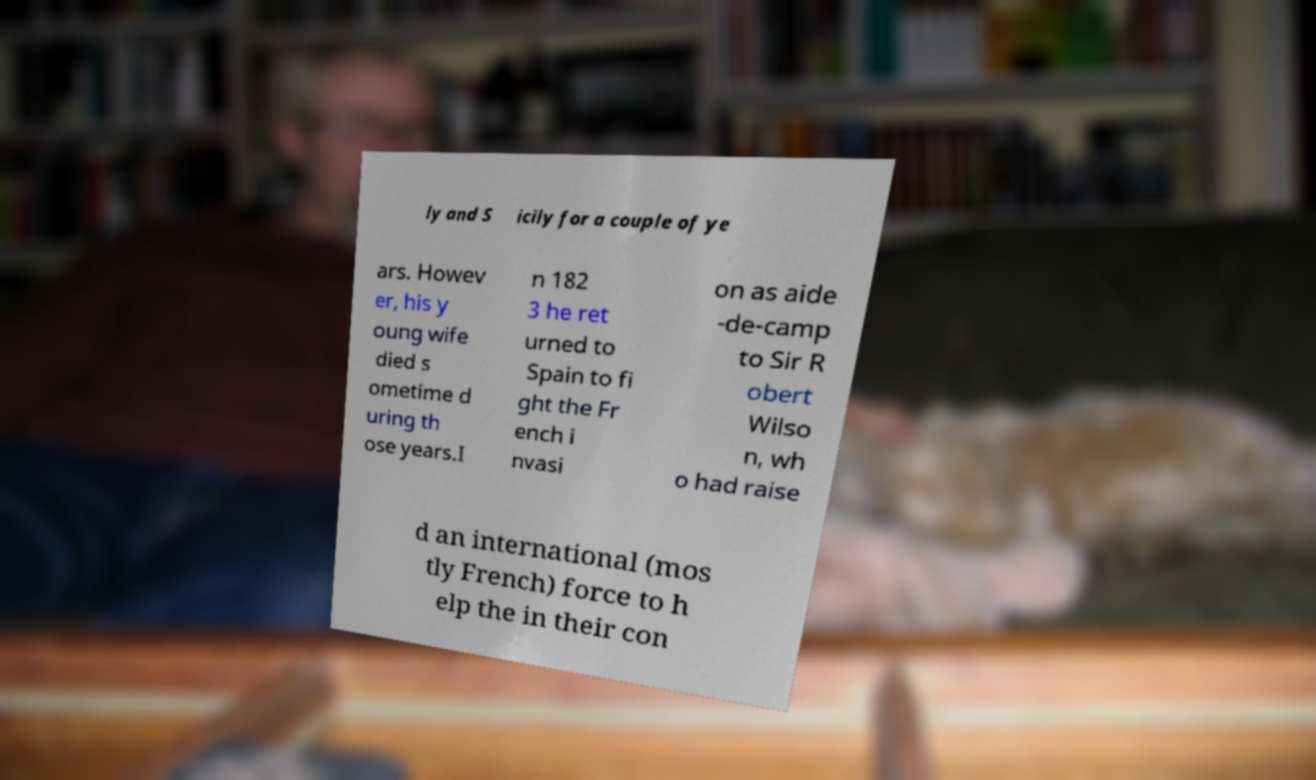Could you assist in decoding the text presented in this image and type it out clearly? ly and S icily for a couple of ye ars. Howev er, his y oung wife died s ometime d uring th ose years.I n 182 3 he ret urned to Spain to fi ght the Fr ench i nvasi on as aide -de-camp to Sir R obert Wilso n, wh o had raise d an international (mos tly French) force to h elp the in their con 